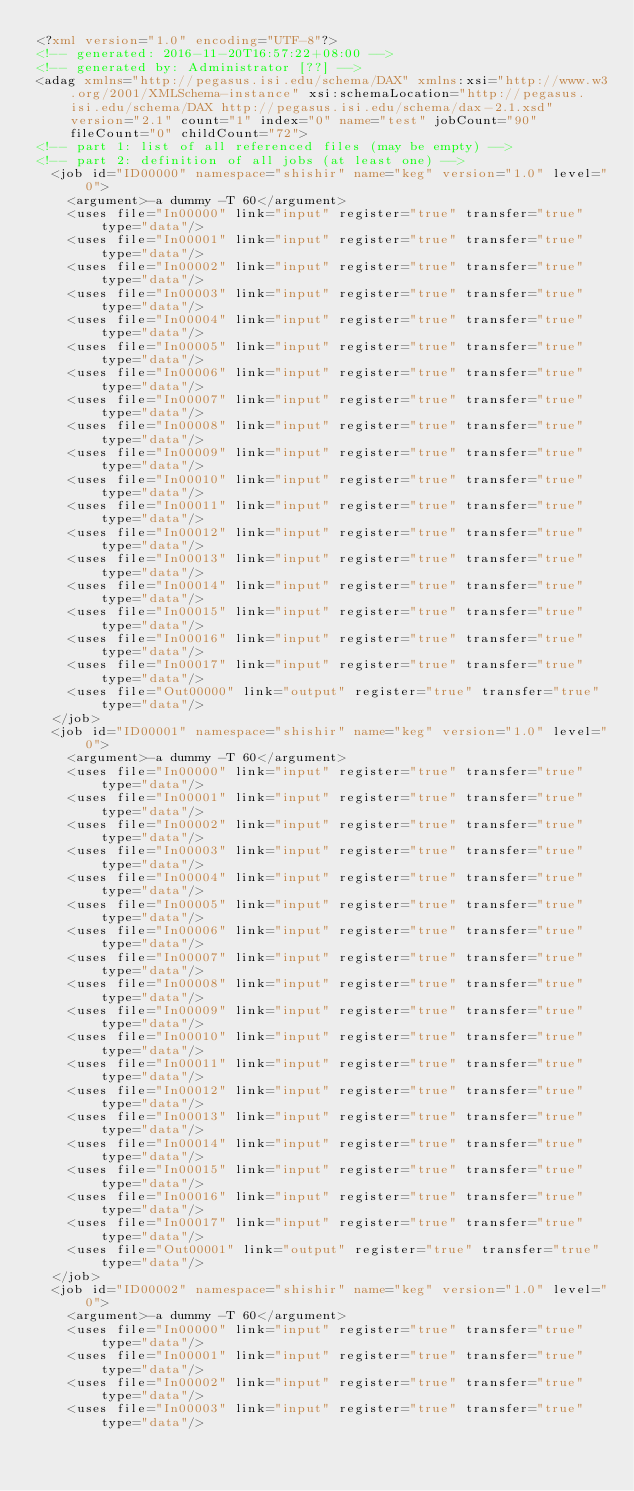<code> <loc_0><loc_0><loc_500><loc_500><_XML_><?xml version="1.0" encoding="UTF-8"?>
<!-- generated: 2016-11-20T16:57:22+08:00 -->
<!-- generated by: Administrator [??] -->
<adag xmlns="http://pegasus.isi.edu/schema/DAX" xmlns:xsi="http://www.w3.org/2001/XMLSchema-instance" xsi:schemaLocation="http://pegasus.isi.edu/schema/DAX http://pegasus.isi.edu/schema/dax-2.1.xsd" version="2.1" count="1" index="0" name="test" jobCount="90" fileCount="0" childCount="72">
<!-- part 1: list of all referenced files (may be empty) -->
<!-- part 2: definition of all jobs (at least one) -->
  <job id="ID00000" namespace="shishir" name="keg" version="1.0" level="0">
    <argument>-a dummy -T 60</argument>
    <uses file="In00000" link="input" register="true" transfer="true" type="data"/>
    <uses file="In00001" link="input" register="true" transfer="true" type="data"/>
    <uses file="In00002" link="input" register="true" transfer="true" type="data"/>
    <uses file="In00003" link="input" register="true" transfer="true" type="data"/>
    <uses file="In00004" link="input" register="true" transfer="true" type="data"/>
    <uses file="In00005" link="input" register="true" transfer="true" type="data"/>
    <uses file="In00006" link="input" register="true" transfer="true" type="data"/>
    <uses file="In00007" link="input" register="true" transfer="true" type="data"/>
    <uses file="In00008" link="input" register="true" transfer="true" type="data"/>
    <uses file="In00009" link="input" register="true" transfer="true" type="data"/>
    <uses file="In00010" link="input" register="true" transfer="true" type="data"/>
    <uses file="In00011" link="input" register="true" transfer="true" type="data"/>
    <uses file="In00012" link="input" register="true" transfer="true" type="data"/>
    <uses file="In00013" link="input" register="true" transfer="true" type="data"/>
    <uses file="In00014" link="input" register="true" transfer="true" type="data"/>
    <uses file="In00015" link="input" register="true" transfer="true" type="data"/>
    <uses file="In00016" link="input" register="true" transfer="true" type="data"/>
    <uses file="In00017" link="input" register="true" transfer="true" type="data"/>
    <uses file="Out00000" link="output" register="true" transfer="true" type="data"/>
  </job>
  <job id="ID00001" namespace="shishir" name="keg" version="1.0" level="0">
    <argument>-a dummy -T 60</argument>
    <uses file="In00000" link="input" register="true" transfer="true" type="data"/>
    <uses file="In00001" link="input" register="true" transfer="true" type="data"/>
    <uses file="In00002" link="input" register="true" transfer="true" type="data"/>
    <uses file="In00003" link="input" register="true" transfer="true" type="data"/>
    <uses file="In00004" link="input" register="true" transfer="true" type="data"/>
    <uses file="In00005" link="input" register="true" transfer="true" type="data"/>
    <uses file="In00006" link="input" register="true" transfer="true" type="data"/>
    <uses file="In00007" link="input" register="true" transfer="true" type="data"/>
    <uses file="In00008" link="input" register="true" transfer="true" type="data"/>
    <uses file="In00009" link="input" register="true" transfer="true" type="data"/>
    <uses file="In00010" link="input" register="true" transfer="true" type="data"/>
    <uses file="In00011" link="input" register="true" transfer="true" type="data"/>
    <uses file="In00012" link="input" register="true" transfer="true" type="data"/>
    <uses file="In00013" link="input" register="true" transfer="true" type="data"/>
    <uses file="In00014" link="input" register="true" transfer="true" type="data"/>
    <uses file="In00015" link="input" register="true" transfer="true" type="data"/>
    <uses file="In00016" link="input" register="true" transfer="true" type="data"/>
    <uses file="In00017" link="input" register="true" transfer="true" type="data"/>
    <uses file="Out00001" link="output" register="true" transfer="true" type="data"/>
  </job>
  <job id="ID00002" namespace="shishir" name="keg" version="1.0" level="0">
    <argument>-a dummy -T 60</argument>
    <uses file="In00000" link="input" register="true" transfer="true" type="data"/>
    <uses file="In00001" link="input" register="true" transfer="true" type="data"/>
    <uses file="In00002" link="input" register="true" transfer="true" type="data"/>
    <uses file="In00003" link="input" register="true" transfer="true" type="data"/></code> 